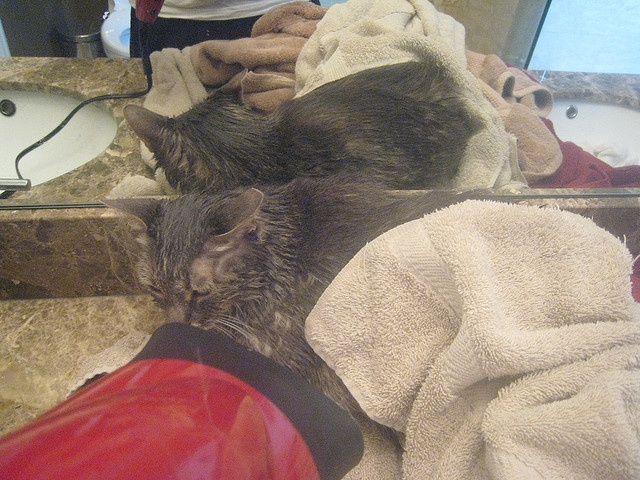Describe the objects in this image and their specific colors. I can see cat in black and gray tones, hair drier in black, brown, and gray tones, cat in black, gray, and tan tones, sink in black, lightgray, darkgray, and gray tones, and people in black, darkgray, and gray tones in this image. 